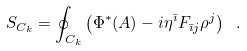<formula> <loc_0><loc_0><loc_500><loc_500>S _ { C _ { k } } = \oint _ { C _ { k } } \left ( \Phi ^ { * } ( A ) - i \eta ^ { \bar { \imath } } F _ { \bar { \imath } j } \rho ^ { j } \right ) \ .</formula> 